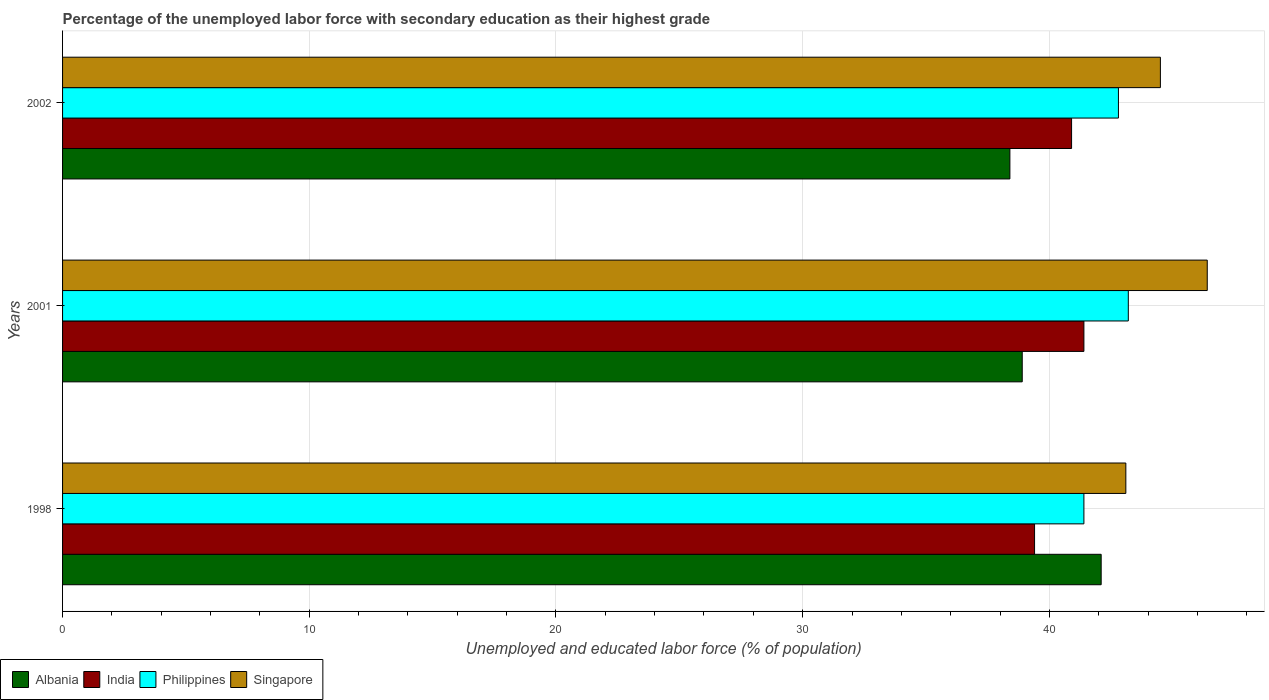How many different coloured bars are there?
Provide a succinct answer. 4. Are the number of bars on each tick of the Y-axis equal?
Keep it short and to the point. Yes. How many bars are there on the 3rd tick from the top?
Provide a succinct answer. 4. How many bars are there on the 2nd tick from the bottom?
Offer a terse response. 4. In how many cases, is the number of bars for a given year not equal to the number of legend labels?
Make the answer very short. 0. What is the percentage of the unemployed labor force with secondary education in Philippines in 2001?
Provide a succinct answer. 43.2. Across all years, what is the maximum percentage of the unemployed labor force with secondary education in India?
Offer a very short reply. 41.4. Across all years, what is the minimum percentage of the unemployed labor force with secondary education in Philippines?
Your answer should be very brief. 41.4. In which year was the percentage of the unemployed labor force with secondary education in Singapore maximum?
Provide a succinct answer. 2001. What is the total percentage of the unemployed labor force with secondary education in India in the graph?
Offer a terse response. 121.7. What is the difference between the percentage of the unemployed labor force with secondary education in Albania in 1998 and that in 2002?
Give a very brief answer. 3.7. What is the difference between the percentage of the unemployed labor force with secondary education in Albania in 2001 and the percentage of the unemployed labor force with secondary education in India in 2002?
Offer a very short reply. -2. What is the average percentage of the unemployed labor force with secondary education in Philippines per year?
Offer a terse response. 42.47. In the year 2002, what is the difference between the percentage of the unemployed labor force with secondary education in India and percentage of the unemployed labor force with secondary education in Albania?
Your response must be concise. 2.5. In how many years, is the percentage of the unemployed labor force with secondary education in Albania greater than 46 %?
Your answer should be very brief. 0. What is the ratio of the percentage of the unemployed labor force with secondary education in India in 1998 to that in 2001?
Your response must be concise. 0.95. What is the difference between the highest and the second highest percentage of the unemployed labor force with secondary education in Singapore?
Offer a very short reply. 1.9. What is the difference between the highest and the lowest percentage of the unemployed labor force with secondary education in Albania?
Offer a very short reply. 3.7. Is the sum of the percentage of the unemployed labor force with secondary education in Singapore in 2001 and 2002 greater than the maximum percentage of the unemployed labor force with secondary education in Philippines across all years?
Your answer should be very brief. Yes. Is it the case that in every year, the sum of the percentage of the unemployed labor force with secondary education in Albania and percentage of the unemployed labor force with secondary education in Singapore is greater than the sum of percentage of the unemployed labor force with secondary education in India and percentage of the unemployed labor force with secondary education in Philippines?
Provide a succinct answer. Yes. What does the 1st bar from the top in 2002 represents?
Your response must be concise. Singapore. Is it the case that in every year, the sum of the percentage of the unemployed labor force with secondary education in India and percentage of the unemployed labor force with secondary education in Singapore is greater than the percentage of the unemployed labor force with secondary education in Albania?
Your answer should be compact. Yes. Are all the bars in the graph horizontal?
Provide a short and direct response. Yes. Does the graph contain any zero values?
Make the answer very short. No. Where does the legend appear in the graph?
Your answer should be very brief. Bottom left. How many legend labels are there?
Ensure brevity in your answer.  4. How are the legend labels stacked?
Give a very brief answer. Horizontal. What is the title of the graph?
Give a very brief answer. Percentage of the unemployed labor force with secondary education as their highest grade. What is the label or title of the X-axis?
Your answer should be compact. Unemployed and educated labor force (% of population). What is the Unemployed and educated labor force (% of population) in Albania in 1998?
Keep it short and to the point. 42.1. What is the Unemployed and educated labor force (% of population) of India in 1998?
Keep it short and to the point. 39.4. What is the Unemployed and educated labor force (% of population) of Philippines in 1998?
Your response must be concise. 41.4. What is the Unemployed and educated labor force (% of population) in Singapore in 1998?
Give a very brief answer. 43.1. What is the Unemployed and educated labor force (% of population) in Albania in 2001?
Your response must be concise. 38.9. What is the Unemployed and educated labor force (% of population) of India in 2001?
Your response must be concise. 41.4. What is the Unemployed and educated labor force (% of population) of Philippines in 2001?
Keep it short and to the point. 43.2. What is the Unemployed and educated labor force (% of population) in Singapore in 2001?
Make the answer very short. 46.4. What is the Unemployed and educated labor force (% of population) of Albania in 2002?
Keep it short and to the point. 38.4. What is the Unemployed and educated labor force (% of population) in India in 2002?
Your answer should be compact. 40.9. What is the Unemployed and educated labor force (% of population) in Philippines in 2002?
Ensure brevity in your answer.  42.8. What is the Unemployed and educated labor force (% of population) of Singapore in 2002?
Ensure brevity in your answer.  44.5. Across all years, what is the maximum Unemployed and educated labor force (% of population) of Albania?
Offer a terse response. 42.1. Across all years, what is the maximum Unemployed and educated labor force (% of population) in India?
Offer a very short reply. 41.4. Across all years, what is the maximum Unemployed and educated labor force (% of population) of Philippines?
Your answer should be very brief. 43.2. Across all years, what is the maximum Unemployed and educated labor force (% of population) of Singapore?
Provide a short and direct response. 46.4. Across all years, what is the minimum Unemployed and educated labor force (% of population) in Albania?
Provide a short and direct response. 38.4. Across all years, what is the minimum Unemployed and educated labor force (% of population) of India?
Keep it short and to the point. 39.4. Across all years, what is the minimum Unemployed and educated labor force (% of population) of Philippines?
Your answer should be very brief. 41.4. Across all years, what is the minimum Unemployed and educated labor force (% of population) of Singapore?
Give a very brief answer. 43.1. What is the total Unemployed and educated labor force (% of population) in Albania in the graph?
Provide a succinct answer. 119.4. What is the total Unemployed and educated labor force (% of population) in India in the graph?
Provide a short and direct response. 121.7. What is the total Unemployed and educated labor force (% of population) of Philippines in the graph?
Offer a terse response. 127.4. What is the total Unemployed and educated labor force (% of population) in Singapore in the graph?
Your answer should be compact. 134. What is the difference between the Unemployed and educated labor force (% of population) of India in 1998 and that in 2001?
Keep it short and to the point. -2. What is the difference between the Unemployed and educated labor force (% of population) in Philippines in 1998 and that in 2001?
Ensure brevity in your answer.  -1.8. What is the difference between the Unemployed and educated labor force (% of population) of Singapore in 1998 and that in 2002?
Ensure brevity in your answer.  -1.4. What is the difference between the Unemployed and educated labor force (% of population) in Albania in 2001 and that in 2002?
Offer a terse response. 0.5. What is the difference between the Unemployed and educated labor force (% of population) of Philippines in 2001 and that in 2002?
Provide a short and direct response. 0.4. What is the difference between the Unemployed and educated labor force (% of population) in Albania in 1998 and the Unemployed and educated labor force (% of population) in India in 2001?
Your answer should be compact. 0.7. What is the difference between the Unemployed and educated labor force (% of population) of Albania in 1998 and the Unemployed and educated labor force (% of population) of Philippines in 2001?
Offer a very short reply. -1.1. What is the difference between the Unemployed and educated labor force (% of population) of Albania in 1998 and the Unemployed and educated labor force (% of population) of Singapore in 2001?
Offer a very short reply. -4.3. What is the difference between the Unemployed and educated labor force (% of population) in India in 1998 and the Unemployed and educated labor force (% of population) in Philippines in 2001?
Your response must be concise. -3.8. What is the difference between the Unemployed and educated labor force (% of population) of India in 1998 and the Unemployed and educated labor force (% of population) of Singapore in 2001?
Your response must be concise. -7. What is the difference between the Unemployed and educated labor force (% of population) of India in 1998 and the Unemployed and educated labor force (% of population) of Philippines in 2002?
Offer a very short reply. -3.4. What is the difference between the Unemployed and educated labor force (% of population) of India in 1998 and the Unemployed and educated labor force (% of population) of Singapore in 2002?
Your response must be concise. -5.1. What is the difference between the Unemployed and educated labor force (% of population) of Philippines in 1998 and the Unemployed and educated labor force (% of population) of Singapore in 2002?
Keep it short and to the point. -3.1. What is the difference between the Unemployed and educated labor force (% of population) in Albania in 2001 and the Unemployed and educated labor force (% of population) in Philippines in 2002?
Your answer should be compact. -3.9. What is the difference between the Unemployed and educated labor force (% of population) in Albania in 2001 and the Unemployed and educated labor force (% of population) in Singapore in 2002?
Provide a succinct answer. -5.6. What is the difference between the Unemployed and educated labor force (% of population) in India in 2001 and the Unemployed and educated labor force (% of population) in Philippines in 2002?
Give a very brief answer. -1.4. What is the difference between the Unemployed and educated labor force (% of population) in India in 2001 and the Unemployed and educated labor force (% of population) in Singapore in 2002?
Offer a terse response. -3.1. What is the average Unemployed and educated labor force (% of population) in Albania per year?
Give a very brief answer. 39.8. What is the average Unemployed and educated labor force (% of population) in India per year?
Offer a terse response. 40.57. What is the average Unemployed and educated labor force (% of population) in Philippines per year?
Make the answer very short. 42.47. What is the average Unemployed and educated labor force (% of population) in Singapore per year?
Your answer should be compact. 44.67. In the year 1998, what is the difference between the Unemployed and educated labor force (% of population) in Albania and Unemployed and educated labor force (% of population) in India?
Offer a very short reply. 2.7. In the year 1998, what is the difference between the Unemployed and educated labor force (% of population) in Albania and Unemployed and educated labor force (% of population) in Singapore?
Provide a short and direct response. -1. In the year 1998, what is the difference between the Unemployed and educated labor force (% of population) in India and Unemployed and educated labor force (% of population) in Philippines?
Give a very brief answer. -2. In the year 1998, what is the difference between the Unemployed and educated labor force (% of population) in Philippines and Unemployed and educated labor force (% of population) in Singapore?
Your answer should be compact. -1.7. In the year 2001, what is the difference between the Unemployed and educated labor force (% of population) of Albania and Unemployed and educated labor force (% of population) of India?
Offer a terse response. -2.5. In the year 2001, what is the difference between the Unemployed and educated labor force (% of population) of Albania and Unemployed and educated labor force (% of population) of Philippines?
Ensure brevity in your answer.  -4.3. In the year 2001, what is the difference between the Unemployed and educated labor force (% of population) of Albania and Unemployed and educated labor force (% of population) of Singapore?
Your response must be concise. -7.5. In the year 2001, what is the difference between the Unemployed and educated labor force (% of population) in India and Unemployed and educated labor force (% of population) in Singapore?
Your response must be concise. -5. In the year 2001, what is the difference between the Unemployed and educated labor force (% of population) of Philippines and Unemployed and educated labor force (% of population) of Singapore?
Offer a very short reply. -3.2. In the year 2002, what is the difference between the Unemployed and educated labor force (% of population) of Albania and Unemployed and educated labor force (% of population) of Singapore?
Give a very brief answer. -6.1. In the year 2002, what is the difference between the Unemployed and educated labor force (% of population) of India and Unemployed and educated labor force (% of population) of Philippines?
Keep it short and to the point. -1.9. In the year 2002, what is the difference between the Unemployed and educated labor force (% of population) in Philippines and Unemployed and educated labor force (% of population) in Singapore?
Your answer should be compact. -1.7. What is the ratio of the Unemployed and educated labor force (% of population) in Albania in 1998 to that in 2001?
Ensure brevity in your answer.  1.08. What is the ratio of the Unemployed and educated labor force (% of population) in India in 1998 to that in 2001?
Give a very brief answer. 0.95. What is the ratio of the Unemployed and educated labor force (% of population) of Singapore in 1998 to that in 2001?
Give a very brief answer. 0.93. What is the ratio of the Unemployed and educated labor force (% of population) of Albania in 1998 to that in 2002?
Give a very brief answer. 1.1. What is the ratio of the Unemployed and educated labor force (% of population) of India in 1998 to that in 2002?
Your answer should be compact. 0.96. What is the ratio of the Unemployed and educated labor force (% of population) in Philippines in 1998 to that in 2002?
Your response must be concise. 0.97. What is the ratio of the Unemployed and educated labor force (% of population) in Singapore in 1998 to that in 2002?
Your answer should be very brief. 0.97. What is the ratio of the Unemployed and educated labor force (% of population) in India in 2001 to that in 2002?
Your answer should be compact. 1.01. What is the ratio of the Unemployed and educated labor force (% of population) in Philippines in 2001 to that in 2002?
Your answer should be very brief. 1.01. What is the ratio of the Unemployed and educated labor force (% of population) of Singapore in 2001 to that in 2002?
Provide a short and direct response. 1.04. What is the difference between the highest and the second highest Unemployed and educated labor force (% of population) in India?
Your response must be concise. 0.5. What is the difference between the highest and the second highest Unemployed and educated labor force (% of population) in Philippines?
Provide a short and direct response. 0.4. What is the difference between the highest and the second highest Unemployed and educated labor force (% of population) in Singapore?
Make the answer very short. 1.9. What is the difference between the highest and the lowest Unemployed and educated labor force (% of population) of Albania?
Provide a succinct answer. 3.7. What is the difference between the highest and the lowest Unemployed and educated labor force (% of population) of India?
Offer a terse response. 2. 